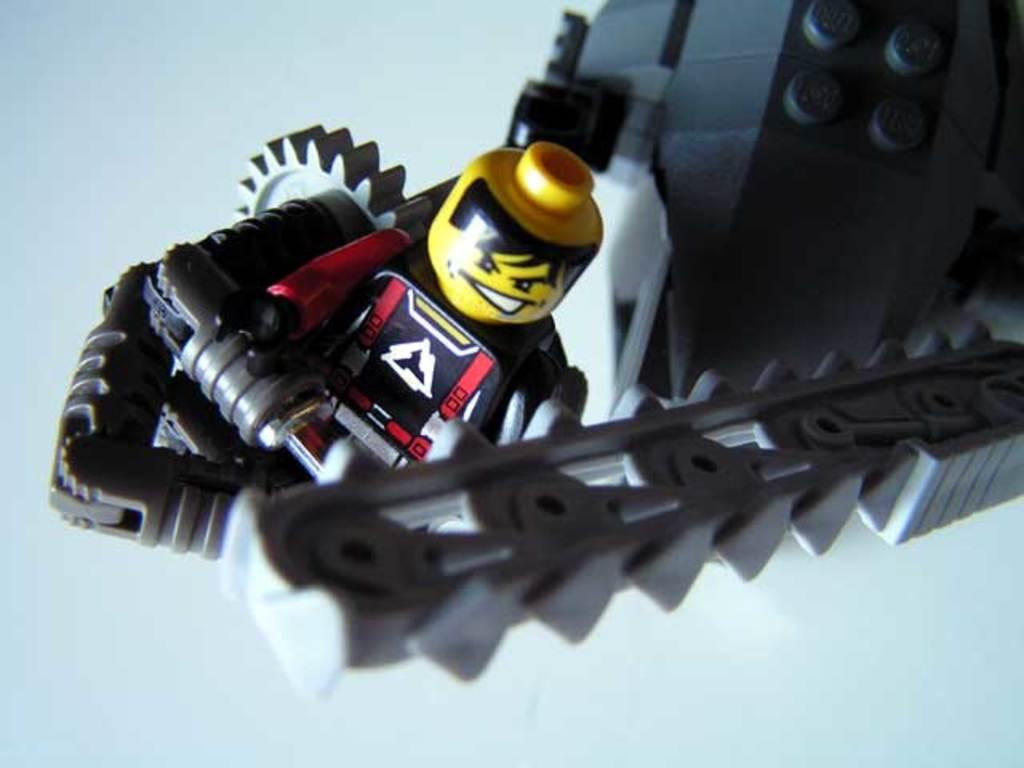What object can be seen in the image? There is a toy in the image. What color is the background of the image? The background of the image is white. What type of education can be seen in the image? There is no indication of education in the image; it features a toy and a white background. 